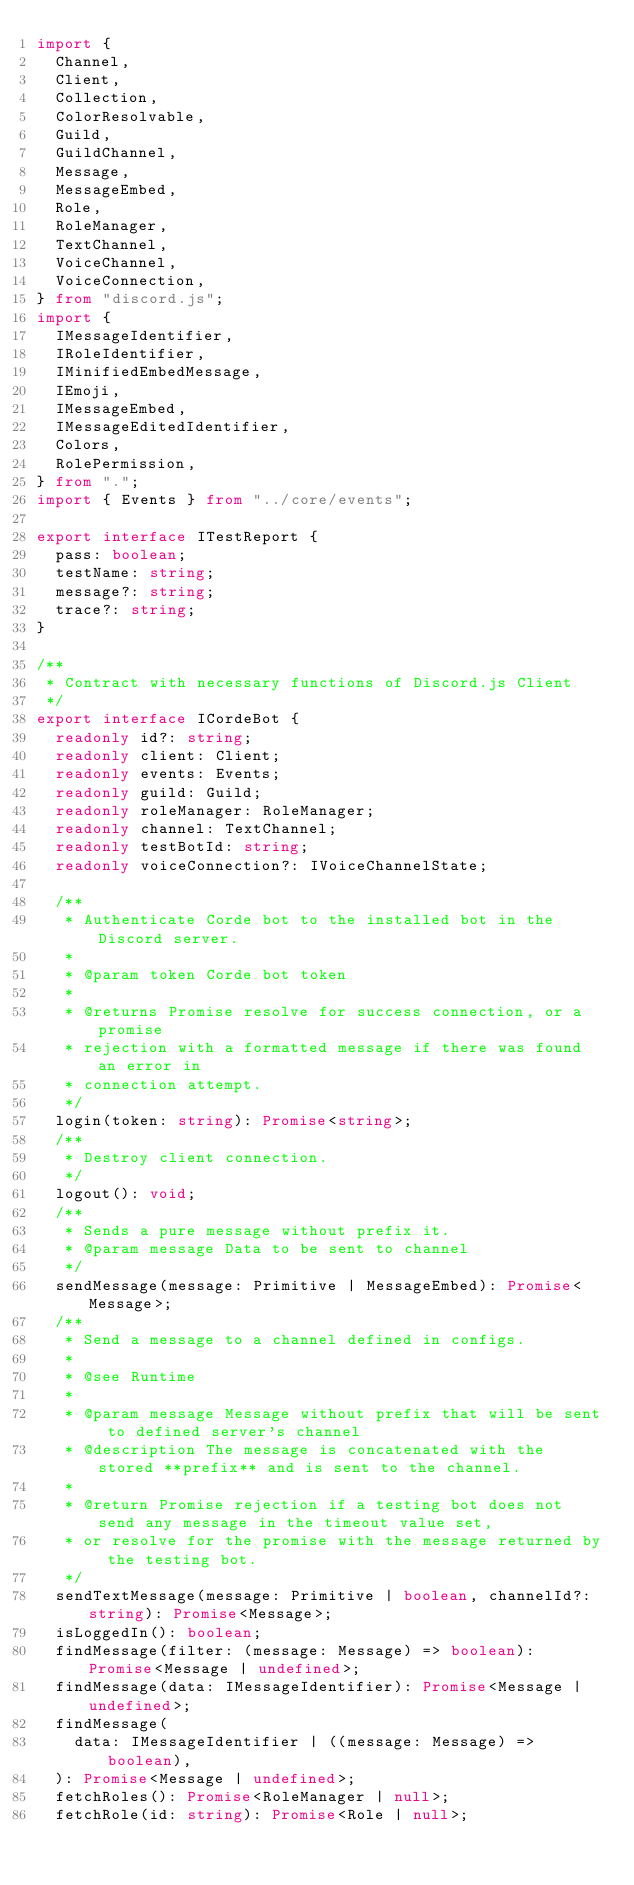Convert code to text. <code><loc_0><loc_0><loc_500><loc_500><_TypeScript_>import {
  Channel,
  Client,
  Collection,
  ColorResolvable,
  Guild,
  GuildChannel,
  Message,
  MessageEmbed,
  Role,
  RoleManager,
  TextChannel,
  VoiceChannel,
  VoiceConnection,
} from "discord.js";
import {
  IMessageIdentifier,
  IRoleIdentifier,
  IMinifiedEmbedMessage,
  IEmoji,
  IMessageEmbed,
  IMessageEditedIdentifier,
  Colors,
  RolePermission,
} from ".";
import { Events } from "../core/events";

export interface ITestReport {
  pass: boolean;
  testName: string;
  message?: string;
  trace?: string;
}

/**
 * Contract with necessary functions of Discord.js Client
 */
export interface ICordeBot {
  readonly id?: string;
  readonly client: Client;
  readonly events: Events;
  readonly guild: Guild;
  readonly roleManager: RoleManager;
  readonly channel: TextChannel;
  readonly testBotId: string;
  readonly voiceConnection?: IVoiceChannelState;

  /**
   * Authenticate Corde bot to the installed bot in the Discord server.
   *
   * @param token Corde bot token
   *
   * @returns Promise resolve for success connection, or a promise
   * rejection with a formatted message if there was found an error in
   * connection attempt.
   */
  login(token: string): Promise<string>;
  /**
   * Destroy client connection.
   */
  logout(): void;
  /**
   * Sends a pure message without prefix it.
   * @param message Data to be sent to channel
   */
  sendMessage(message: Primitive | MessageEmbed): Promise<Message>;
  /**
   * Send a message to a channel defined in configs.
   *
   * @see Runtime
   *
   * @param message Message without prefix that will be sent to defined server's channel
   * @description The message is concatenated with the stored **prefix** and is sent to the channel.
   *
   * @return Promise rejection if a testing bot does not send any message in the timeout value set,
   * or resolve for the promise with the message returned by the testing bot.
   */
  sendTextMessage(message: Primitive | boolean, channelId?: string): Promise<Message>;
  isLoggedIn(): boolean;
  findMessage(filter: (message: Message) => boolean): Promise<Message | undefined>;
  findMessage(data: IMessageIdentifier): Promise<Message | undefined>;
  findMessage(
    data: IMessageIdentifier | ((message: Message) => boolean),
  ): Promise<Message | undefined>;
  fetchRoles(): Promise<RoleManager | null>;
  fetchRole(id: string): Promise<Role | null>;</code> 